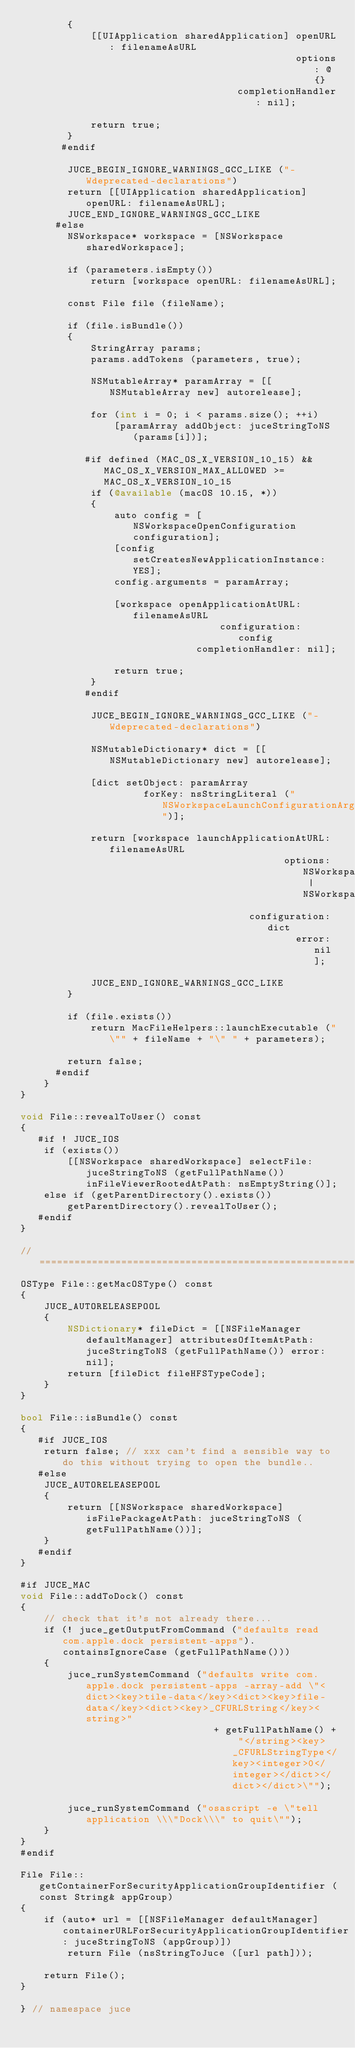<code> <loc_0><loc_0><loc_500><loc_500><_ObjectiveC_>        {
            [[UIApplication sharedApplication] openURL: filenameAsURL
                                               options: @{}
                                     completionHandler: nil];

            return true;
        }
       #endif

        JUCE_BEGIN_IGNORE_WARNINGS_GCC_LIKE ("-Wdeprecated-declarations")
        return [[UIApplication sharedApplication] openURL: filenameAsURL];
        JUCE_END_IGNORE_WARNINGS_GCC_LIKE
      #else
        NSWorkspace* workspace = [NSWorkspace sharedWorkspace];

        if (parameters.isEmpty())
            return [workspace openURL: filenameAsURL];

        const File file (fileName);

        if (file.isBundle())
        {
            StringArray params;
            params.addTokens (parameters, true);

            NSMutableArray* paramArray = [[NSMutableArray new] autorelease];

            for (int i = 0; i < params.size(); ++i)
                [paramArray addObject: juceStringToNS (params[i])];

           #if defined (MAC_OS_X_VERSION_10_15) && MAC_OS_X_VERSION_MAX_ALLOWED >= MAC_OS_X_VERSION_10_15
            if (@available (macOS 10.15, *))
            {
                auto config = [NSWorkspaceOpenConfiguration configuration];
                [config setCreatesNewApplicationInstance: YES];
                config.arguments = paramArray;

                [workspace openApplicationAtURL: filenameAsURL
                                  configuration: config
                              completionHandler: nil];

                return true;
            }
           #endif

            JUCE_BEGIN_IGNORE_WARNINGS_GCC_LIKE ("-Wdeprecated-declarations")

            NSMutableDictionary* dict = [[NSMutableDictionary new] autorelease];

            [dict setObject: paramArray
                     forKey: nsStringLiteral ("NSWorkspaceLaunchConfigurationArguments")];

            return [workspace launchApplicationAtURL: filenameAsURL
                                             options: NSWorkspaceLaunchDefault | NSWorkspaceLaunchNewInstance
                                       configuration: dict
                                               error: nil];

            JUCE_END_IGNORE_WARNINGS_GCC_LIKE
        }

        if (file.exists())
            return MacFileHelpers::launchExecutable ("\"" + fileName + "\" " + parameters);

        return false;
      #endif
    }
}

void File::revealToUser() const
{
   #if ! JUCE_IOS
    if (exists())
        [[NSWorkspace sharedWorkspace] selectFile: juceStringToNS (getFullPathName()) inFileViewerRootedAtPath: nsEmptyString()];
    else if (getParentDirectory().exists())
        getParentDirectory().revealToUser();
   #endif
}

//==============================================================================
OSType File::getMacOSType() const
{
    JUCE_AUTORELEASEPOOL
    {
        NSDictionary* fileDict = [[NSFileManager defaultManager] attributesOfItemAtPath: juceStringToNS (getFullPathName()) error: nil];
        return [fileDict fileHFSTypeCode];
    }
}

bool File::isBundle() const
{
   #if JUCE_IOS
    return false; // xxx can't find a sensible way to do this without trying to open the bundle..
   #else
    JUCE_AUTORELEASEPOOL
    {
        return [[NSWorkspace sharedWorkspace] isFilePackageAtPath: juceStringToNS (getFullPathName())];
    }
   #endif
}

#if JUCE_MAC
void File::addToDock() const
{
    // check that it's not already there...
    if (! juce_getOutputFromCommand ("defaults read com.apple.dock persistent-apps").containsIgnoreCase (getFullPathName()))
    {
        juce_runSystemCommand ("defaults write com.apple.dock persistent-apps -array-add \"<dict><key>tile-data</key><dict><key>file-data</key><dict><key>_CFURLString</key><string>"
                                 + getFullPathName() + "</string><key>_CFURLStringType</key><integer>0</integer></dict></dict></dict>\"");

        juce_runSystemCommand ("osascript -e \"tell application \\\"Dock\\\" to quit\"");
    }
}
#endif

File File::getContainerForSecurityApplicationGroupIdentifier (const String& appGroup)
{
    if (auto* url = [[NSFileManager defaultManager] containerURLForSecurityApplicationGroupIdentifier: juceStringToNS (appGroup)])
        return File (nsStringToJuce ([url path]));

    return File();
}

} // namespace juce
</code> 